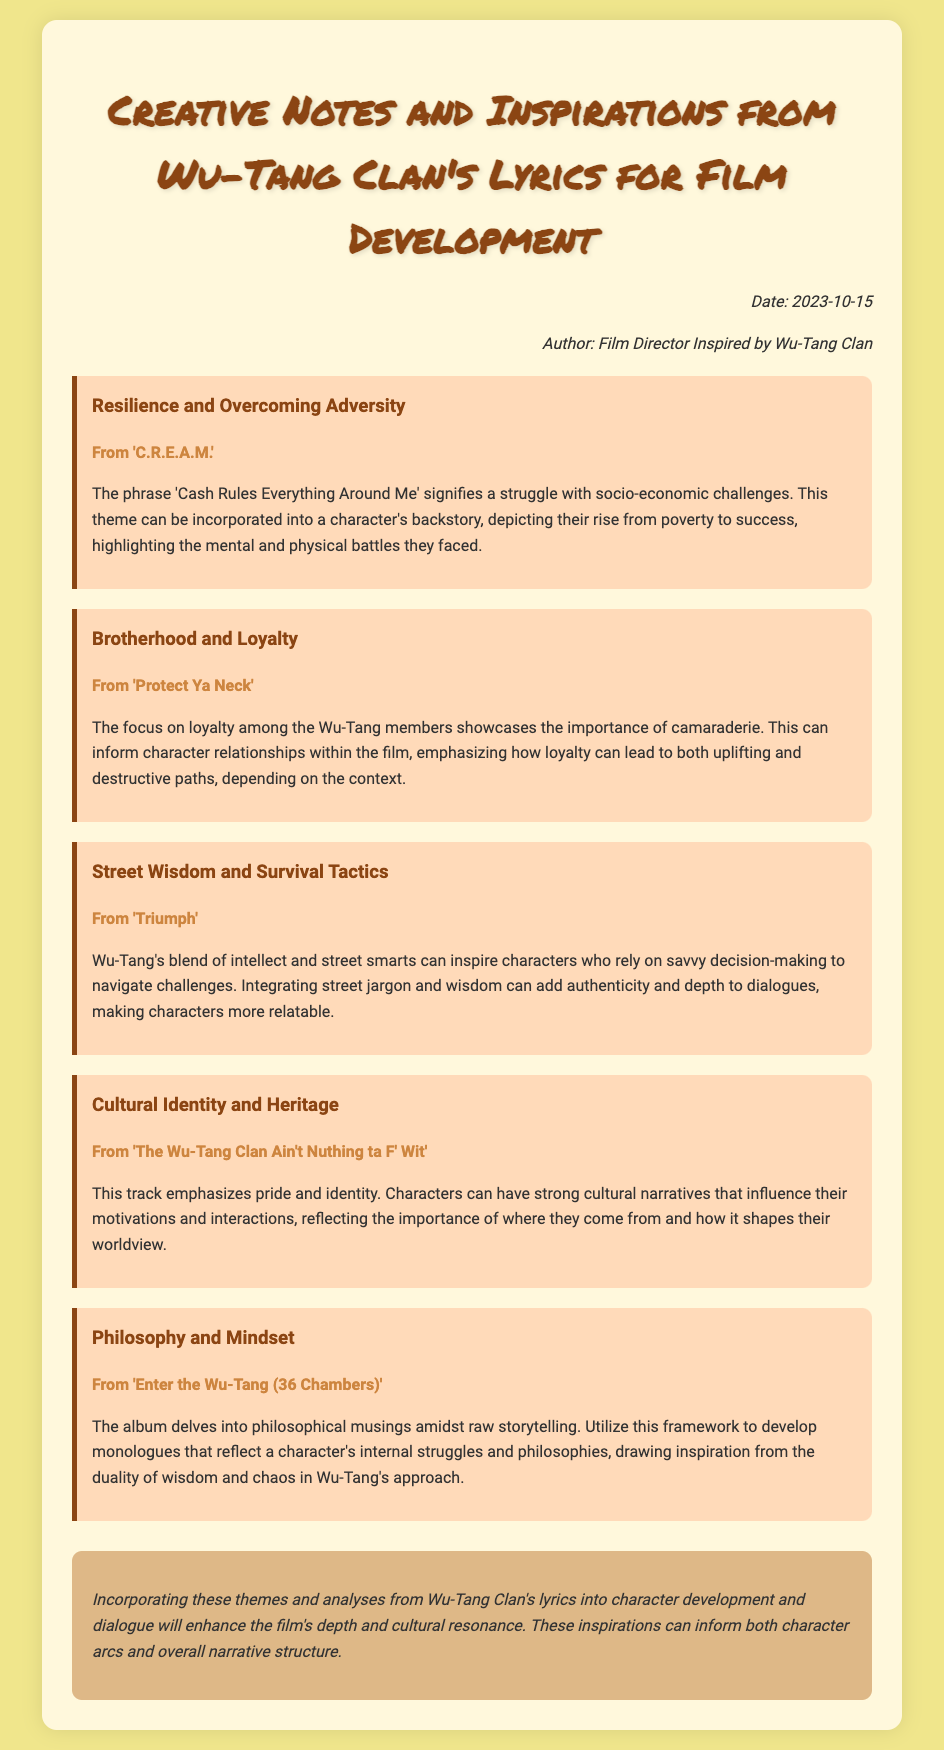What is the title of the memo? The title of the memo is presented at the top and highlights the main focus of the document.
Answer: Creative Notes and Inspirations from Wu-Tang Clan's Lyrics for Film Development What date was the memo written? The memo includes the date in the information section, indicating when it was created.
Answer: 2023-10-15 Who is the author of the memo? The memo specifies the author in the header, which reflects their identity and perspective.
Answer: Film Director Inspired by Wu-Tang Clan What is the first theme discussed in the memo? The first theme is highlighted in a specific section and focuses on a key concept from Wu-Tang Clan's lyrics.
Answer: Resilience and Overcoming Adversity Which Wu-Tang song is referenced in relation to brotherhood? The memo cites a specific song in connection to the theme of loyalty and camaraderie among members.
Answer: Protect Ya Neck What philosophical concept is mentioned in the last theme? The last theme addresses a notable aspect of character development, relating to a deeper understanding of life.
Answer: Philosophy and Mindset How many distinct themes are analyzed in the memo? The memo outlines a certain number of themes, each related to different aspects of Wu-Tang Clan's lyrics.
Answer: Five What color is used for the memo's background? The background color is described in the styling of the memo, contributing to its overall aesthetics.
Answer: F0E68C What cultural aspect is emphasized in the lyrics from "The Wu-Tang Clan Ain't Nuthing ta F' Wit"? The memo specifically notes an important influence that shapes character motivations and interactions.
Answer: Cultural Identity and Heritage 